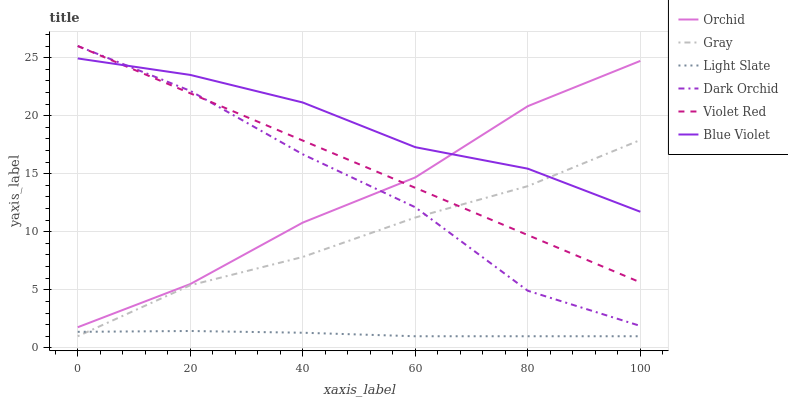Does Light Slate have the minimum area under the curve?
Answer yes or no. Yes. Does Violet Red have the minimum area under the curve?
Answer yes or no. No. Does Violet Red have the maximum area under the curve?
Answer yes or no. No. Is Violet Red the smoothest?
Answer yes or no. Yes. Is Dark Orchid the roughest?
Answer yes or no. Yes. Is Light Slate the smoothest?
Answer yes or no. No. Is Light Slate the roughest?
Answer yes or no. No. Does Violet Red have the lowest value?
Answer yes or no. No. Does Light Slate have the highest value?
Answer yes or no. No. Is Light Slate less than Violet Red?
Answer yes or no. Yes. Is Dark Orchid greater than Light Slate?
Answer yes or no. Yes. Does Light Slate intersect Violet Red?
Answer yes or no. No. 